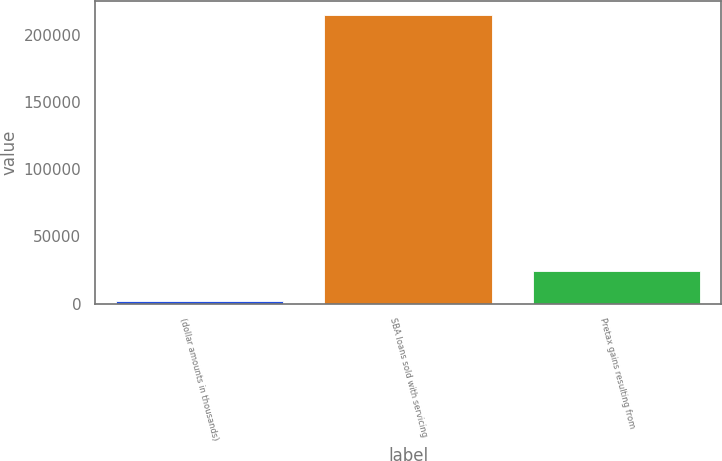<chart> <loc_0><loc_0><loc_500><loc_500><bar_chart><fcel>(dollar amounts in thousands)<fcel>SBA loans sold with servicing<fcel>Pretax gains resulting from<nl><fcel>2014<fcel>214760<fcel>24579<nl></chart> 